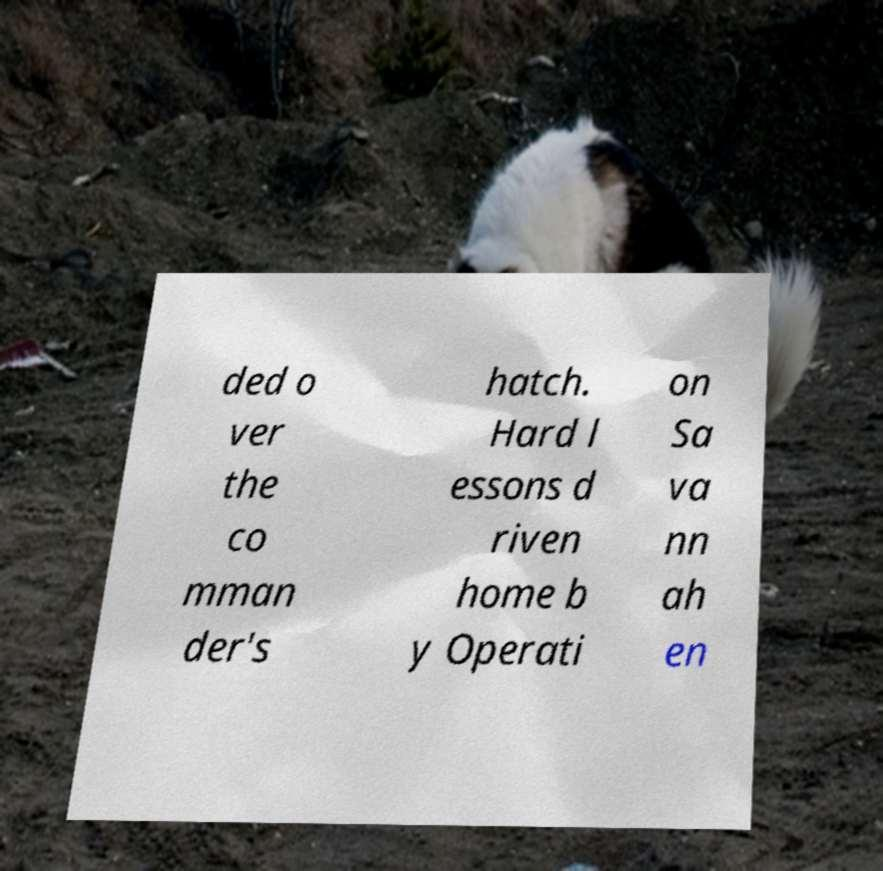Could you extract and type out the text from this image? ded o ver the co mman der's hatch. Hard l essons d riven home b y Operati on Sa va nn ah en 